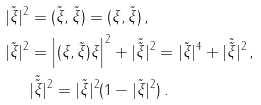<formula> <loc_0><loc_0><loc_500><loc_500>| \tilde { \xi } | ^ { 2 } & = ( \tilde { \xi } , \tilde { \xi } ) = ( \xi , \tilde { \xi } ) \, , \\ | \tilde { \xi } | ^ { 2 } & = \left | ( \xi , \tilde { \xi } ) \xi \right | ^ { 2 } + | \tilde { \tilde { \xi } } | ^ { 2 } = | \tilde { \xi } | ^ { 4 } + | \tilde { \tilde { \xi } } | ^ { 2 } \, , \\ & | \tilde { \tilde { \xi } } | ^ { 2 } = | \tilde { \xi } | ^ { 2 } ( 1 - | \tilde { \xi } | ^ { 2 } ) \, .</formula> 